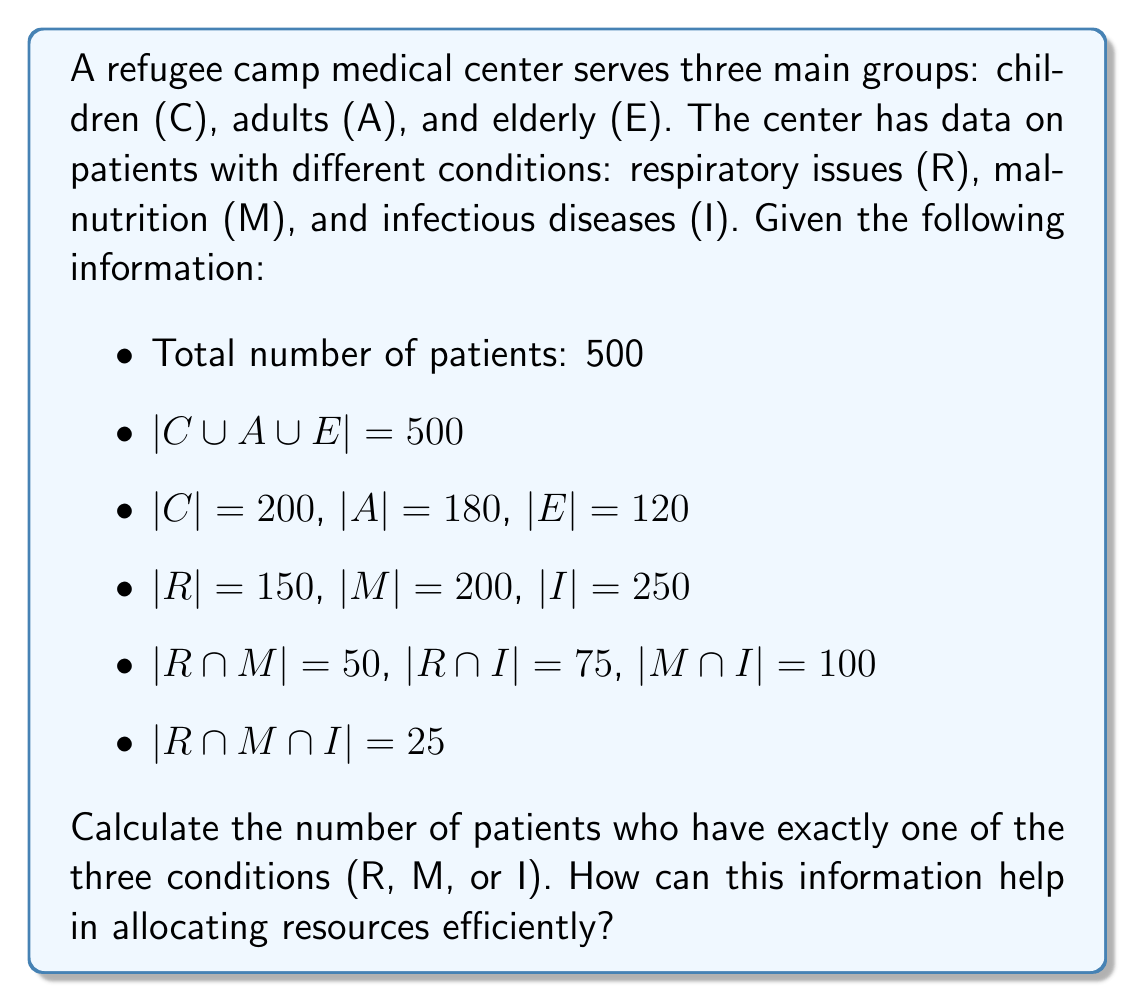Teach me how to tackle this problem. To solve this problem, we'll use the Inclusion-Exclusion Principle from set theory. Let's break it down step by step:

1) First, we need to find the total number of patients with at least one condition:
   $|R \cup M \cup I| = |R| + |M| + |I| - |R \cap M| - |R \cap I| - |M \cap I| + |R \cap M \cap I|$
   
   $= 150 + 200 + 250 - 50 - 75 - 100 + 25 = 400$

2) Now, let's define $X$ as the set of patients with exactly one condition. We can express this as:
   $|X| = |R \cup M \cup I| - |(R \cap M) \cup (R \cap I) \cup (M \cap I)|$

3) We already know $|R \cup M \cup I| = 400$. We need to calculate $|(R \cap M) \cup (R \cap I) \cup (M \cap I)|$:
   $|(R \cap M) \cup (R \cap I) \cup (M \cap I)| = |R \cap M| + |R \cap I| + |M \cap I| - |R \cap M \cap I|$
   $= 50 + 75 + 100 - 25 = 200$

4) Now we can calculate $|X|$:
   $|X| = 400 - 200 = 200$

This information can help in allocating resources efficiently by:
1. Identifying the most common single conditions, allowing for targeted resource allocation.
2. Planning for specialized care units for patients with multiple conditions.
3. Optimizing staff training to address the most prevalent single conditions.
4. Streamlining supply chain management for medications and equipment specific to these conditions.
5. Developing targeted health education programs for prevention and management of the most common single conditions.
Answer: 200 patients have exactly one of the three conditions (R, M, or I). 